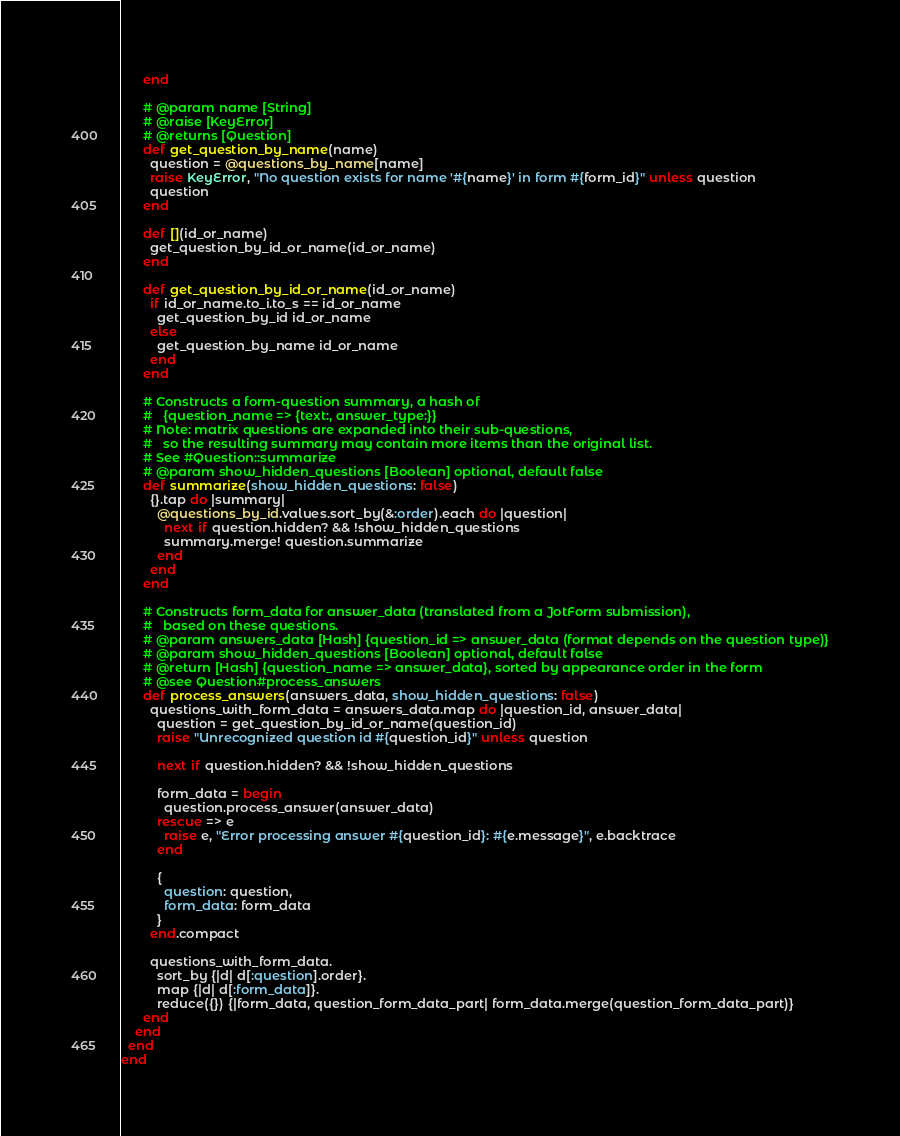Convert code to text. <code><loc_0><loc_0><loc_500><loc_500><_Ruby_>      end

      # @param name [String]
      # @raise [KeyError]
      # @returns [Question]
      def get_question_by_name(name)
        question = @questions_by_name[name]
        raise KeyError, "No question exists for name '#{name}' in form #{form_id}" unless question
        question
      end

      def [](id_or_name)
        get_question_by_id_or_name(id_or_name)
      end

      def get_question_by_id_or_name(id_or_name)
        if id_or_name.to_i.to_s == id_or_name
          get_question_by_id id_or_name
        else
          get_question_by_name id_or_name
        end
      end

      # Constructs a form-question summary, a hash of
      #   {question_name => {text:, answer_type:}}
      # Note: matrix questions are expanded into their sub-questions,
      #   so the resulting summary may contain more items than the original list.
      # See #Question::summarize
      # @param show_hidden_questions [Boolean] optional, default false
      def summarize(show_hidden_questions: false)
        {}.tap do |summary|
          @questions_by_id.values.sort_by(&:order).each do |question|
            next if question.hidden? && !show_hidden_questions
            summary.merge! question.summarize
          end
        end
      end

      # Constructs form_data for answer_data (translated from a JotForm submission),
      #   based on these questions.
      # @param answers_data [Hash] {question_id => answer_data (format depends on the question type)}
      # @param show_hidden_questions [Boolean] optional, default false
      # @return [Hash] {question_name => answer_data}, sorted by appearance order in the form
      # @see Question#process_answers
      def process_answers(answers_data, show_hidden_questions: false)
        questions_with_form_data = answers_data.map do |question_id, answer_data|
          question = get_question_by_id_or_name(question_id)
          raise "Unrecognized question id #{question_id}" unless question

          next if question.hidden? && !show_hidden_questions

          form_data = begin
            question.process_answer(answer_data)
          rescue => e
            raise e, "Error processing answer #{question_id}: #{e.message}", e.backtrace
          end

          {
            question: question,
            form_data: form_data
          }
        end.compact

        questions_with_form_data.
          sort_by {|d| d[:question].order}.
          map {|d| d[:form_data]}.
          reduce({}) {|form_data, question_form_data_part| form_data.merge(question_form_data_part)}
      end
    end
  end
end
</code> 